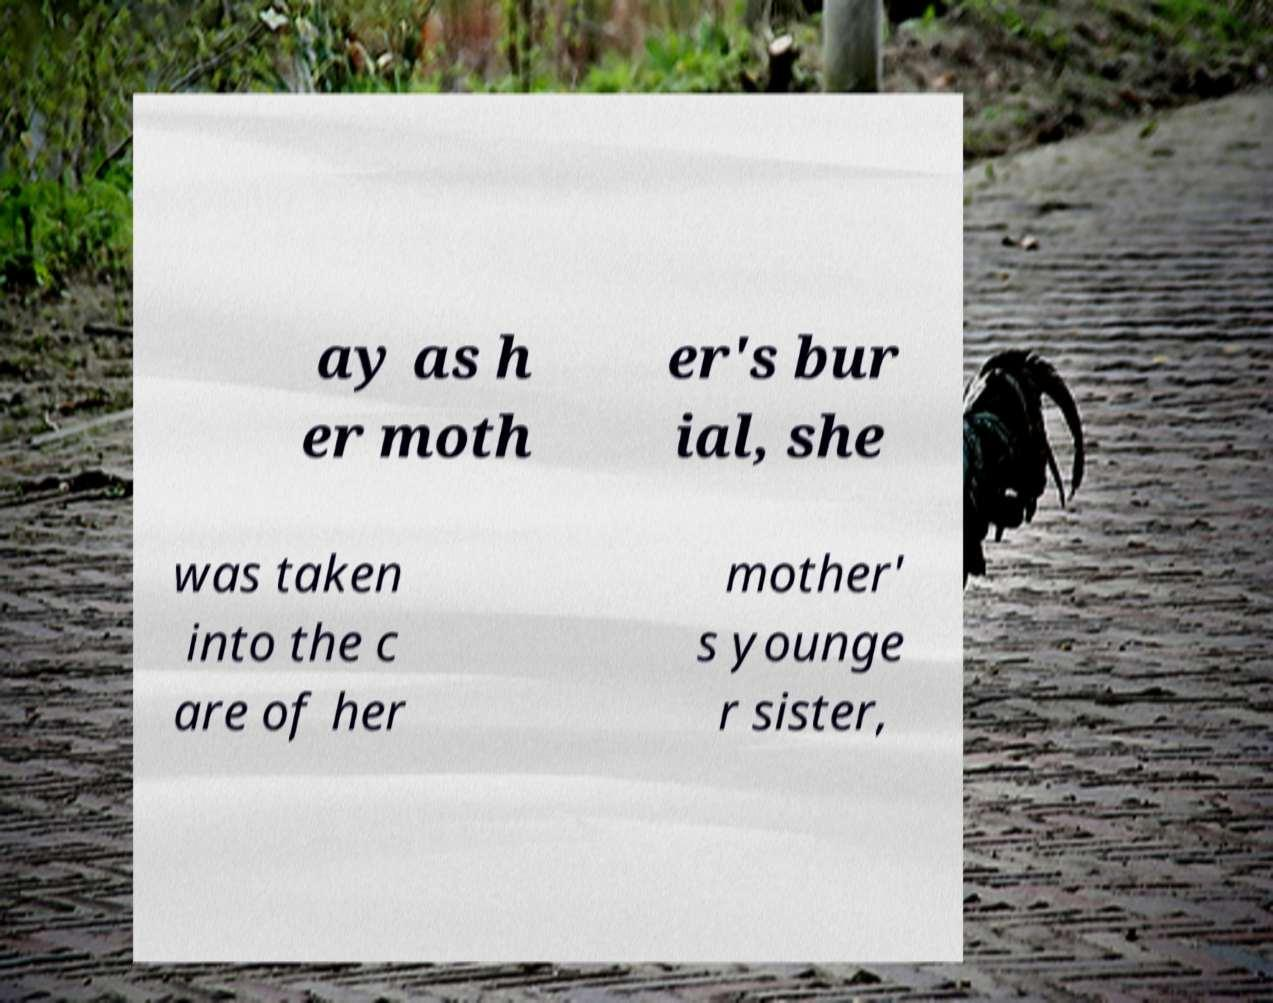Could you assist in decoding the text presented in this image and type it out clearly? ay as h er moth er's bur ial, she was taken into the c are of her mother' s younge r sister, 